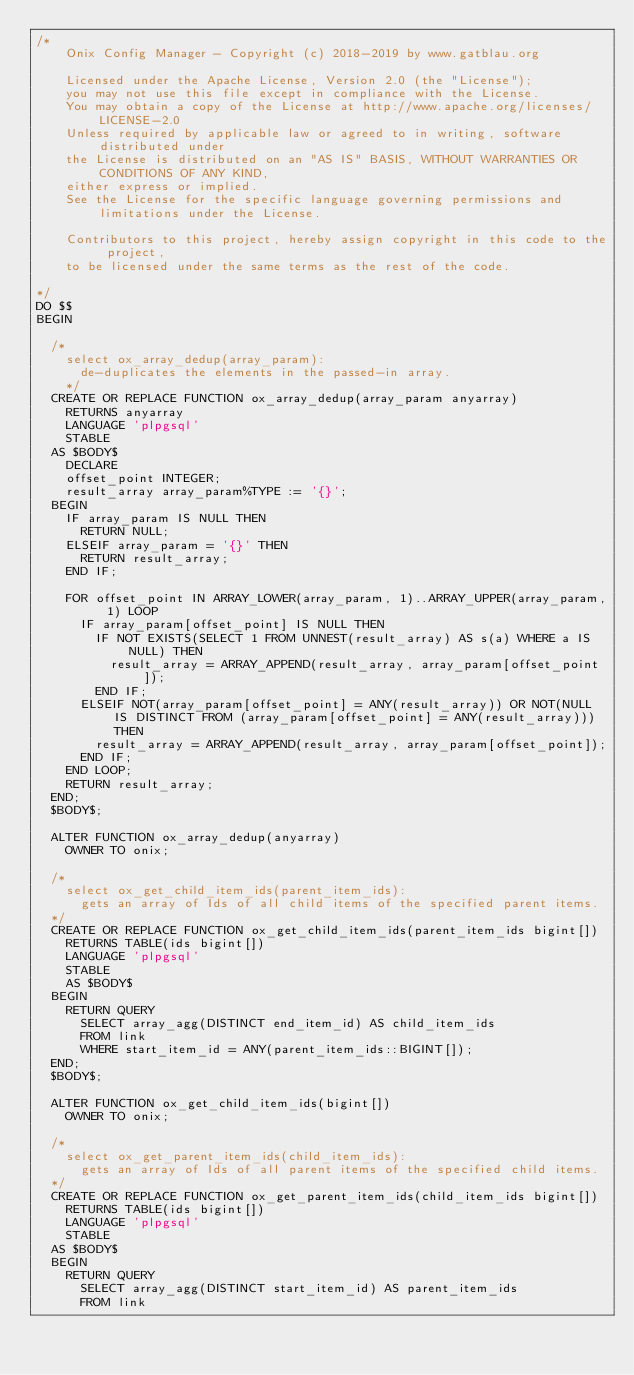<code> <loc_0><loc_0><loc_500><loc_500><_SQL_>/*
    Onix Config Manager - Copyright (c) 2018-2019 by www.gatblau.org

    Licensed under the Apache License, Version 2.0 (the "License");
    you may not use this file except in compliance with the License.
    You may obtain a copy of the License at http://www.apache.org/licenses/LICENSE-2.0
    Unless required by applicable law or agreed to in writing, software distributed under
    the License is distributed on an "AS IS" BASIS, WITHOUT WARRANTIES OR CONDITIONS OF ANY KIND,
    either express or implied.
    See the License for the specific language governing permissions and limitations under the License.

    Contributors to this project, hereby assign copyright in this code to the project,
    to be licensed under the same terms as the rest of the code.

*/
DO $$
BEGIN

  /*
    select ox_array_dedup(array_param):
      de-duplicates the elements in the passed-in array.
    */
  CREATE OR REPLACE FUNCTION ox_array_dedup(array_param anyarray)
    RETURNS anyarray
    LANGUAGE 'plpgsql'
    STABLE
  AS $BODY$
    DECLARE
    offset_point INTEGER;
    result_array array_param%TYPE := '{}';
  BEGIN
    IF array_param IS NULL THEN
      RETURN NULL;
    ELSEIF array_param = '{}' THEN
      RETURN result_array;
    END IF;

    FOR offset_point IN ARRAY_LOWER(array_param, 1)..ARRAY_UPPER(array_param, 1) LOOP
      IF array_param[offset_point] IS NULL THEN
        IF NOT EXISTS(SELECT 1 FROM UNNEST(result_array) AS s(a) WHERE a IS NULL) THEN
          result_array = ARRAY_APPEND(result_array, array_param[offset_point]);
        END IF;
      ELSEIF NOT(array_param[offset_point] = ANY(result_array)) OR NOT(NULL IS DISTINCT FROM (array_param[offset_point] = ANY(result_array))) THEN
        result_array = ARRAY_APPEND(result_array, array_param[offset_point]);
      END IF;
    END LOOP;
    RETURN result_array;
  END;
  $BODY$;

  ALTER FUNCTION ox_array_dedup(anyarray)
    OWNER TO onix;

  /*
    select ox_get_child_item_ids(parent_item_ids):
      gets an array of Ids of all child items of the specified parent items.
  */
  CREATE OR REPLACE FUNCTION ox_get_child_item_ids(parent_item_ids bigint[])
    RETURNS TABLE(ids bigint[])
    LANGUAGE 'plpgsql'
    STABLE
    AS $BODY$
  BEGIN
    RETURN QUERY
      SELECT array_agg(DISTINCT end_item_id) AS child_item_ids
      FROM link
      WHERE start_item_id = ANY(parent_item_ids::BIGINT[]);
  END;
  $BODY$;

  ALTER FUNCTION ox_get_child_item_ids(bigint[])
    OWNER TO onix;

  /*
    select ox_get_parent_item_ids(child_item_ids):
      gets an array of Ids of all parent items of the specified child items.
  */
  CREATE OR REPLACE FUNCTION ox_get_parent_item_ids(child_item_ids bigint[])
    RETURNS TABLE(ids bigint[])
    LANGUAGE 'plpgsql'
    STABLE
  AS $BODY$
  BEGIN
    RETURN QUERY
      SELECT array_agg(DISTINCT start_item_id) AS parent_item_ids
      FROM link</code> 